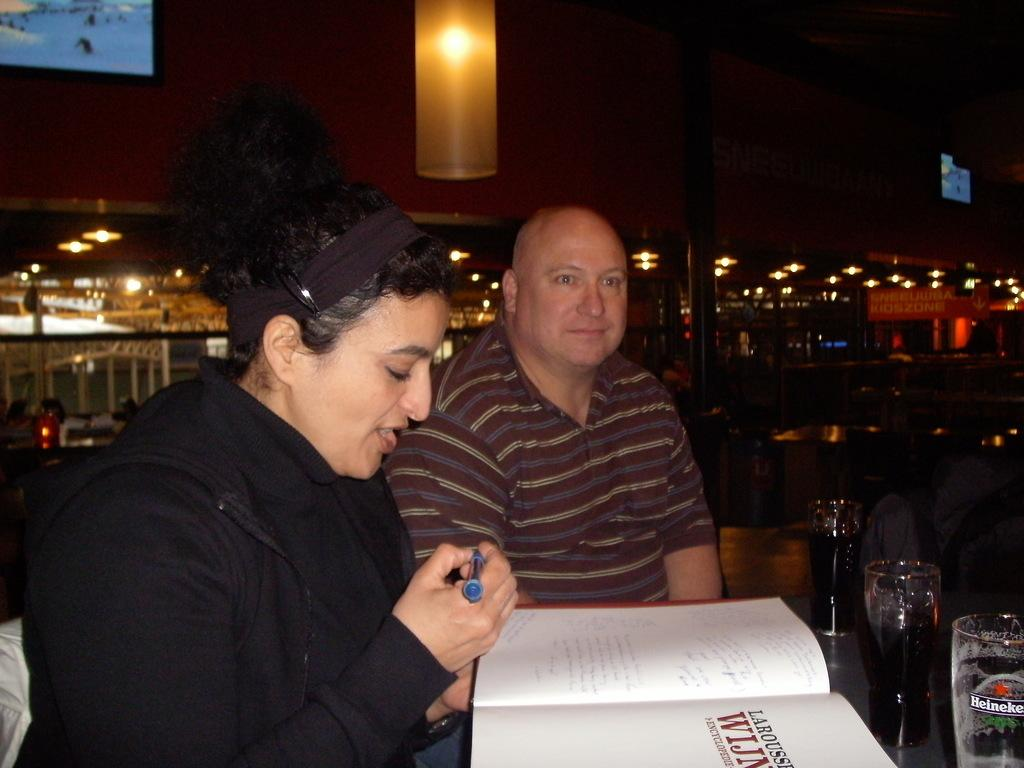What are the two people in the image doing? The two people are sitting in the image. What is one of the people holding? One of the people is holding a pen. What is the other person holding? The other person is holding a book. What can be seen on a surface in the image? There are glasses on a surface in the image. What can be seen in the background of the image? There are lights visible in the background. What type of meat is being cooked on the bridge in the image? There is no bridge or meat present in the image. 